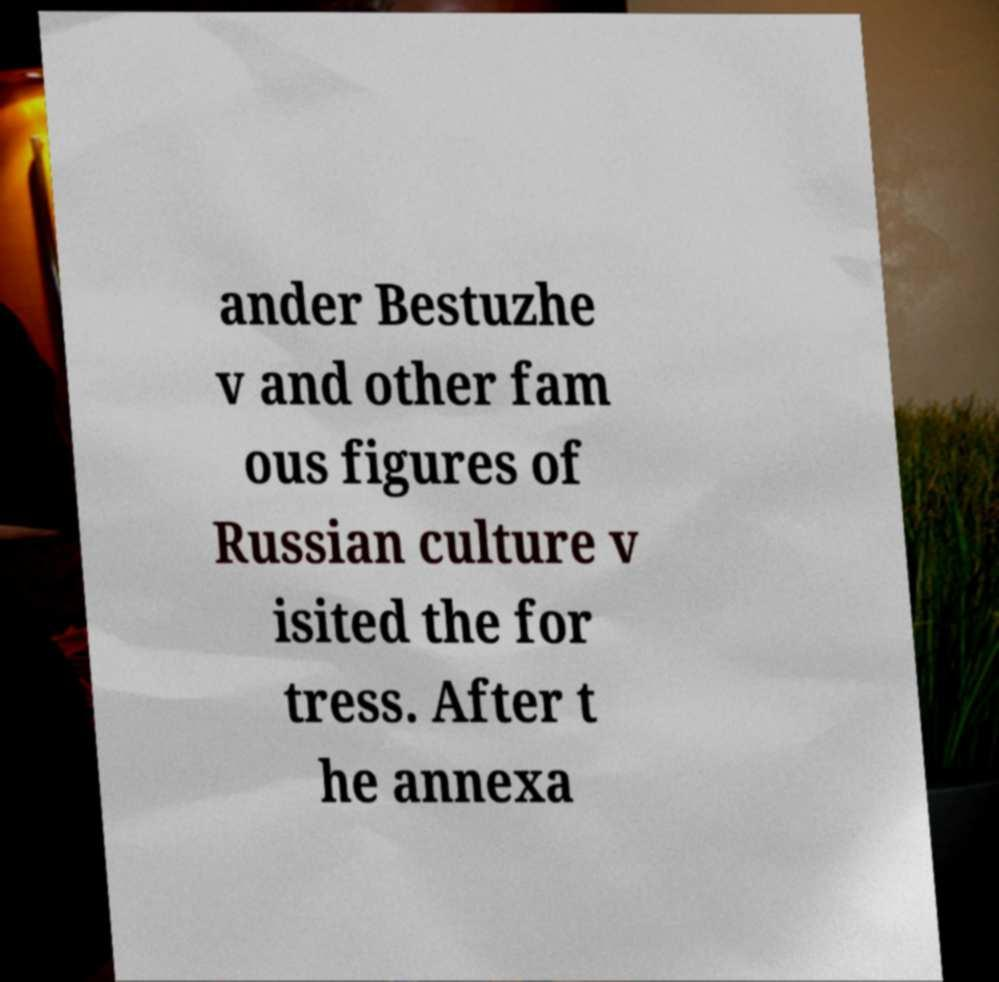Can you read and provide the text displayed in the image?This photo seems to have some interesting text. Can you extract and type it out for me? ander Bestuzhe v and other fam ous figures of Russian culture v isited the for tress. After t he annexa 